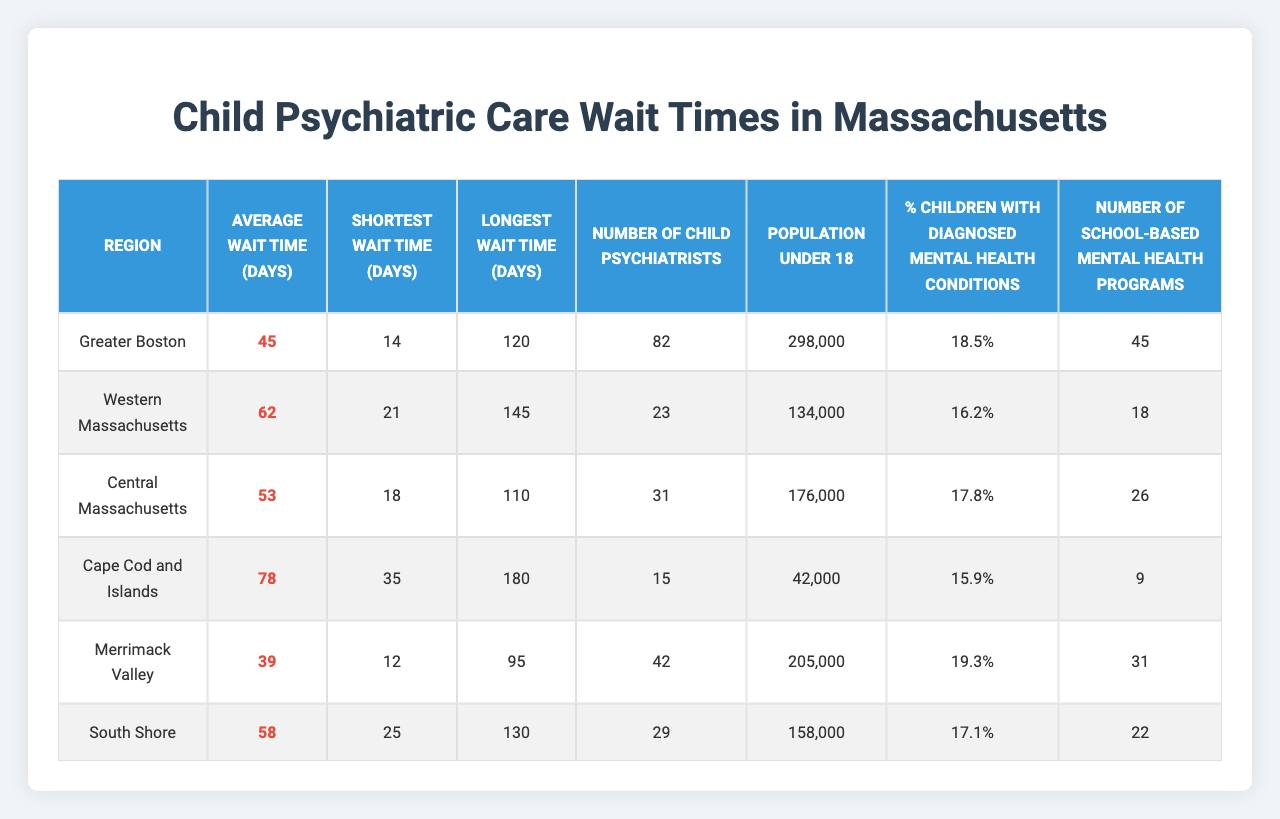What is the average wait time for child psychiatric appointments in Greater Boston? The table shows that the average wait time for Greater Boston is listed as 45 days.
Answer: 45 days Which region has the longest wait time for child psychiatric appointments? The table indicates that Cape Cod and Islands has the longest wait time at 78 days.
Answer: Cape Cod and Islands What is the shortest wait time reported across all regions? The shortest wait time is found in Merrimack Valley, which has a shortest wait time of 12 days.
Answer: 12 days How many child psychiatrists are available in Western Massachusetts? The table specifies that there are 23 child psychiatrists in Western Massachusetts.
Answer: 23 What is the population under 18 in Central Massachusetts? According to the table, Central Massachusetts has a population under 18 of 176,000.
Answer: 176,000 What is the difference in average wait time between the South Shore and Cape Cod and Islands? The average wait time for South Shore is 58 days, while for Cape Cod and Islands it is 78 days. The difference is 78 - 58 = 20 days.
Answer: 20 days Is the percentage of children with diagnosed mental health conditions in Merrimack Valley higher than in Cape Cod and Islands? Merrimack Valley has 19.3% compared to Cape Cod and Islands which has 15.9%. Since 19.3% is greater than 15.9%, the answer is yes.
Answer: Yes What is the total number of child psychiatrists across all regions? By adding the number of child psychiatrists for all regions (82 + 23 + 31 + 15 + 42 + 29), the total is 222.
Answer: 222 How many school-based mental health programs are there in Greater Boston compared to South Shore? Greater Boston has 45 programs, while South Shore has 22. The difference is 45 - 22 = 23 more programs in Greater Boston.
Answer: 23 more programs What is the average percentage of children with diagnosed mental health conditions across all regions? To find this, sum the percentages (18.5 + 16.2 + 17.8 + 15.9 + 19.3 + 17.1 = 104.8) and divide by the number of regions (6). This gives an average of 104.8 / 6 = 17.47%.
Answer: 17.47% 